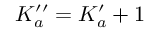<formula> <loc_0><loc_0><loc_500><loc_500>K _ { a } ^ { \prime \prime } = K _ { a } ^ { \prime } + 1</formula> 